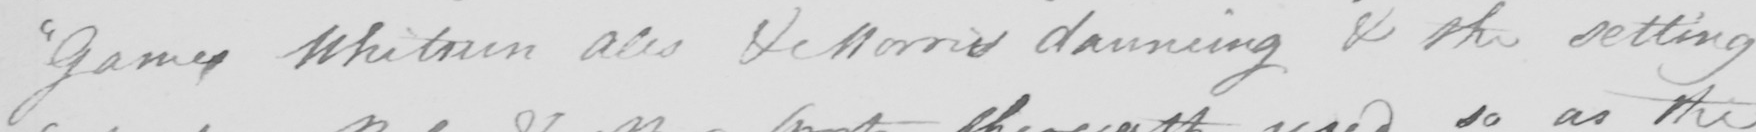Can you read and transcribe this handwriting? " Games Whitsun Ales & Morris dauncing & the setting 